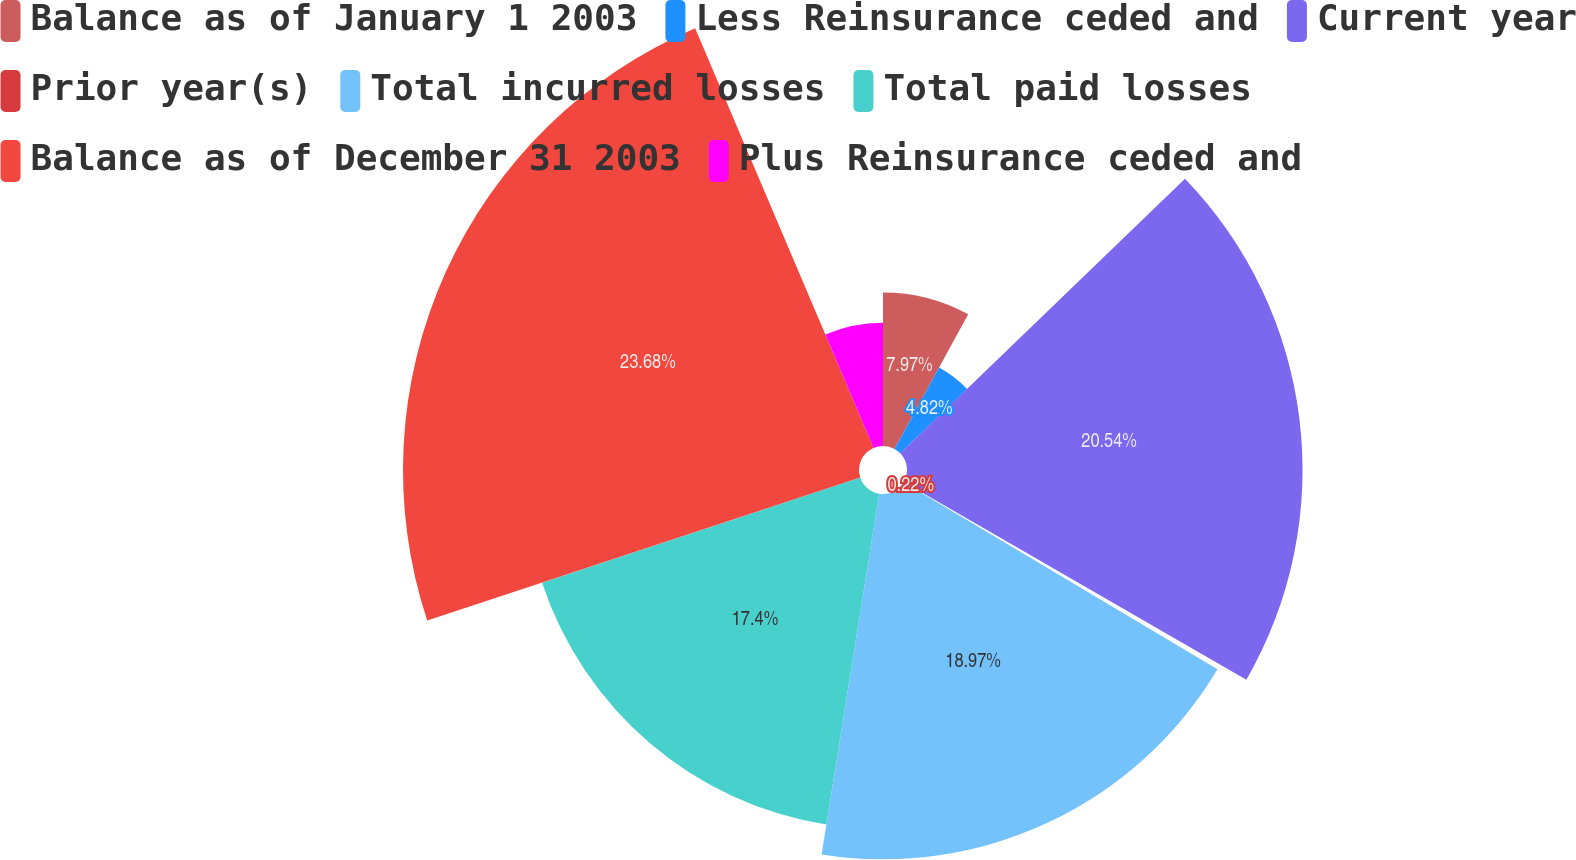Convert chart. <chart><loc_0><loc_0><loc_500><loc_500><pie_chart><fcel>Balance as of January 1 2003<fcel>Less Reinsurance ceded and<fcel>Current year<fcel>Prior year(s)<fcel>Total incurred losses<fcel>Total paid losses<fcel>Balance as of December 31 2003<fcel>Plus Reinsurance ceded and<nl><fcel>7.97%<fcel>4.82%<fcel>20.54%<fcel>0.22%<fcel>18.97%<fcel>17.4%<fcel>23.68%<fcel>6.4%<nl></chart> 